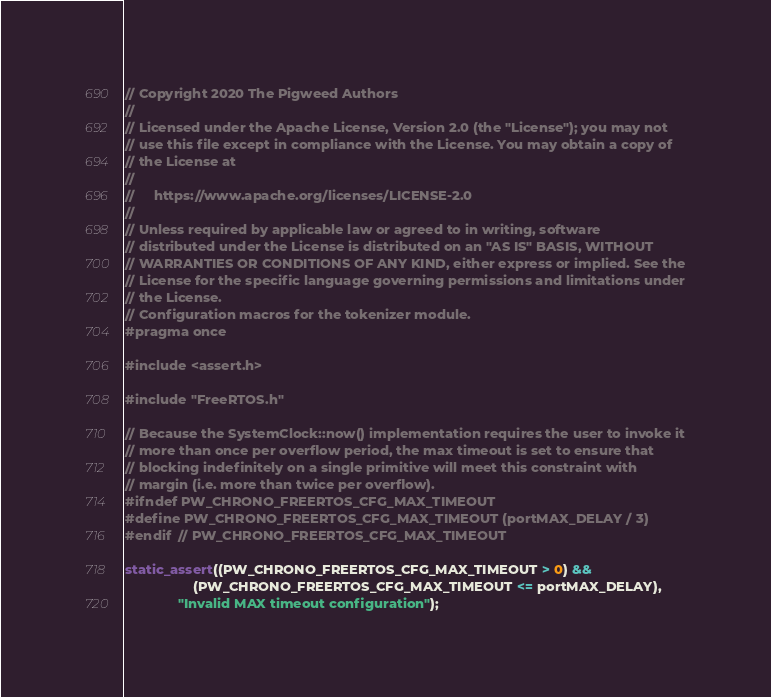<code> <loc_0><loc_0><loc_500><loc_500><_C_>// Copyright 2020 The Pigweed Authors
//
// Licensed under the Apache License, Version 2.0 (the "License"); you may not
// use this file except in compliance with the License. You may obtain a copy of
// the License at
//
//     https://www.apache.org/licenses/LICENSE-2.0
//
// Unless required by applicable law or agreed to in writing, software
// distributed under the License is distributed on an "AS IS" BASIS, WITHOUT
// WARRANTIES OR CONDITIONS OF ANY KIND, either express or implied. See the
// License for the specific language governing permissions and limitations under
// the License.
// Configuration macros for the tokenizer module.
#pragma once

#include <assert.h>

#include "FreeRTOS.h"

// Because the SystemClock::now() implementation requires the user to invoke it
// more than once per overflow period, the max timeout is set to ensure that
// blocking indefinitely on a single primitive will meet this constraint with
// margin (i.e. more than twice per overflow).
#ifndef PW_CHRONO_FREERTOS_CFG_MAX_TIMEOUT
#define PW_CHRONO_FREERTOS_CFG_MAX_TIMEOUT (portMAX_DELAY / 3)
#endif  // PW_CHRONO_FREERTOS_CFG_MAX_TIMEOUT

static_assert((PW_CHRONO_FREERTOS_CFG_MAX_TIMEOUT > 0) &&
                  (PW_CHRONO_FREERTOS_CFG_MAX_TIMEOUT <= portMAX_DELAY),
              "Invalid MAX timeout configuration");
</code> 